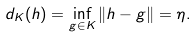Convert formula to latex. <formula><loc_0><loc_0><loc_500><loc_500>d _ { K } ( h ) = \inf _ { g \in K } \| h - g \| = \eta .</formula> 